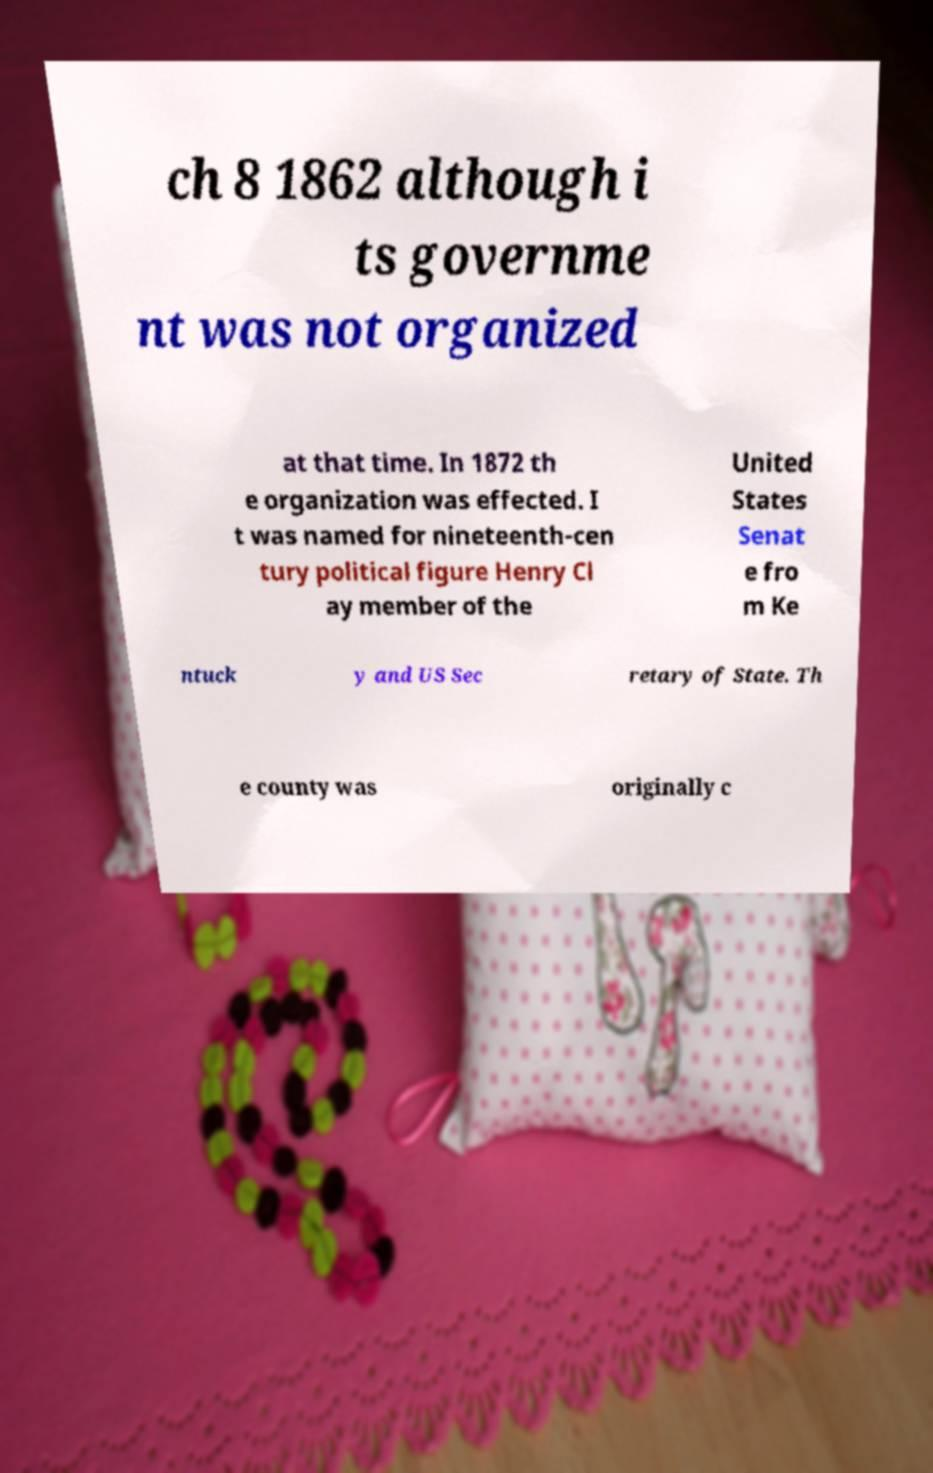Could you assist in decoding the text presented in this image and type it out clearly? ch 8 1862 although i ts governme nt was not organized at that time. In 1872 th e organization was effected. I t was named for nineteenth-cen tury political figure Henry Cl ay member of the United States Senat e fro m Ke ntuck y and US Sec retary of State. Th e county was originally c 